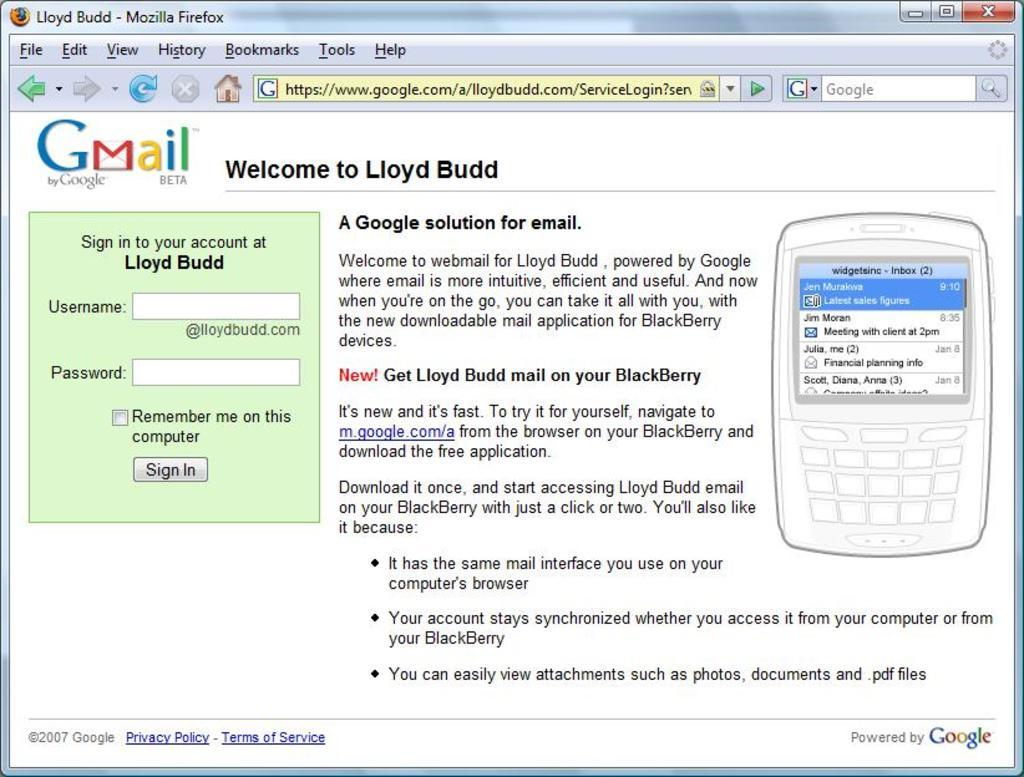<image>
Describe the image concisely. A Gmail account is connected to something called Lloyd Budd. 